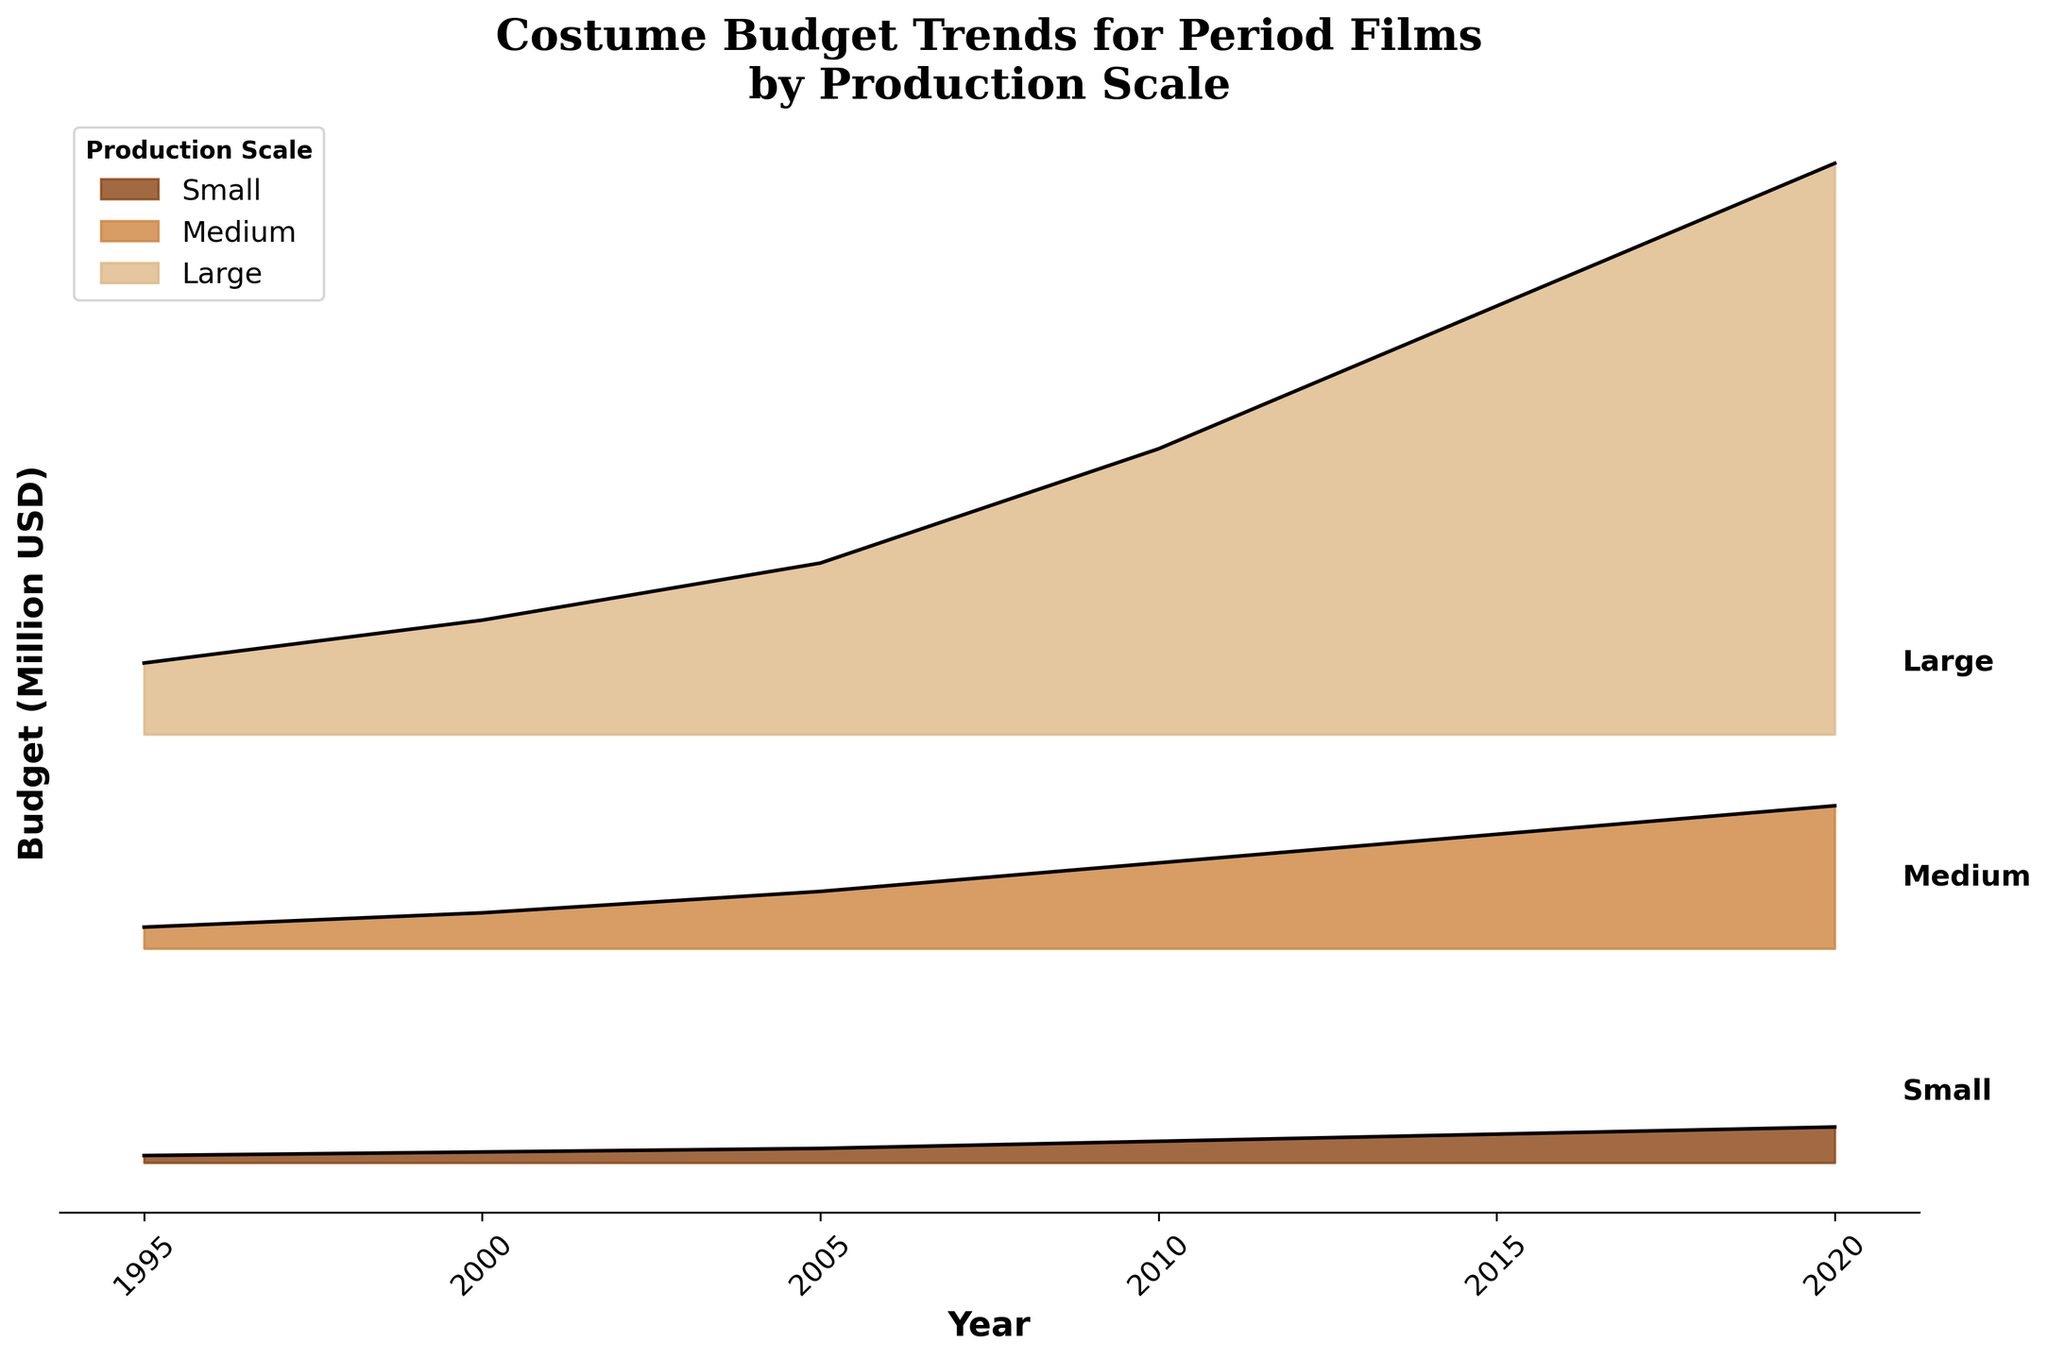What's the title of the ridgeline plot? The title is located at the top center of the plot, and it provides a clear summary of what the plot is about.
Answer: Costume Budget Trends for Period Films by Production Scale What are the years shown on the x-axis? The x-axis contains labels for each year represented in the data, arranged from left to right.
Answer: 1995, 2000, 2005, 2010, 2015, 2020 What is the budget range for small-scale productions in 2010? By referring to the specific segment labeled "Small" in the year 2010, we see the budget range visually represented by the height of the filled area. The y-values for the small-scale production reach up to about 0.15 million USD.
Answer: 150,000 USD How did the budget for large-scale productions change from 2005 to 2020? Look at the topmost segments labeled "Large" at both years (2005 and 2020) and compare their vertical extents. In 2005, the budget was approximately 1.2 million USD, and it increased to 4.0 million USD in 2020.
Answer: Increased What production scale has the highest budget in 2015? Locate the year 2015 on the x-axis and compare the vertical heights of the segments for small, medium, and large-scale productions. The segment for large-scale is the highest.
Answer: Large-scale Which year shows the highest increase in budget for medium-scale productions? Compare the heights of the "Medium" segments across years and identify the year with the largest vertical jump. The budget for medium-scale increased significantly from 2005 (around 0.4 million USD) to 2010 (around 0.6 million USD).
Answer: 2010 What's the budget difference between small and large-scale productions in 2000? Find the data points for both "Small" and "Large" in the year 2000 and calculate the difference. Small is at 0.075 million USD, and Large is at 0.8 million USD, so the difference is 0.8 - 0.075 = 0.725 million USD.
Answer: 725,000 USD In which year did the small-scale production budget exceed 150,000 USD for the first time? Inspect the progression of the small-scale production segments across years and identify when the budget first exceeds 0.15 million USD. In 2010, the budget for small-scale productions reaches 0.15 million USD.
Answer: 2010 How many production scales are represented in the plot? Count the unique segments (each having a different color and label) stacked vertically that appear consistently across the years. The labels indicate there are three scales: Small, Medium, and Large.
Answer: 3 What's the visual trend in budget for all production scales over the years? Observe the general direction of each segment from left (earlier years) to right (later years) and infer the overall trend. All production scales show a consistent increase in budget over the years.
Answer: Increasing trends 